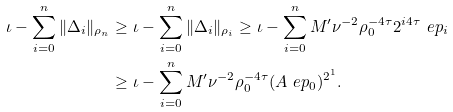Convert formula to latex. <formula><loc_0><loc_0><loc_500><loc_500>\iota - \sum _ { i = 0 } ^ { n } \| \Delta _ { i } \| _ { \rho _ { n } } & \geq \iota - \sum _ { i = 0 } ^ { n } \| \Delta _ { i } \| _ { \rho _ { i } } \geq \iota - \sum _ { i = 0 } ^ { n } M ^ { \prime } \nu ^ { - 2 } \rho _ { 0 } ^ { - 4 \tau } 2 ^ { i 4 \tau } \ e p _ { i } \\ & \geq \iota - \sum _ { i = 0 } ^ { n } M ^ { \prime } \nu ^ { - 2 } \rho _ { 0 } ^ { - 4 \tau } ( A \ e p _ { 0 } ) ^ { 2 ^ { 1 } } .</formula> 